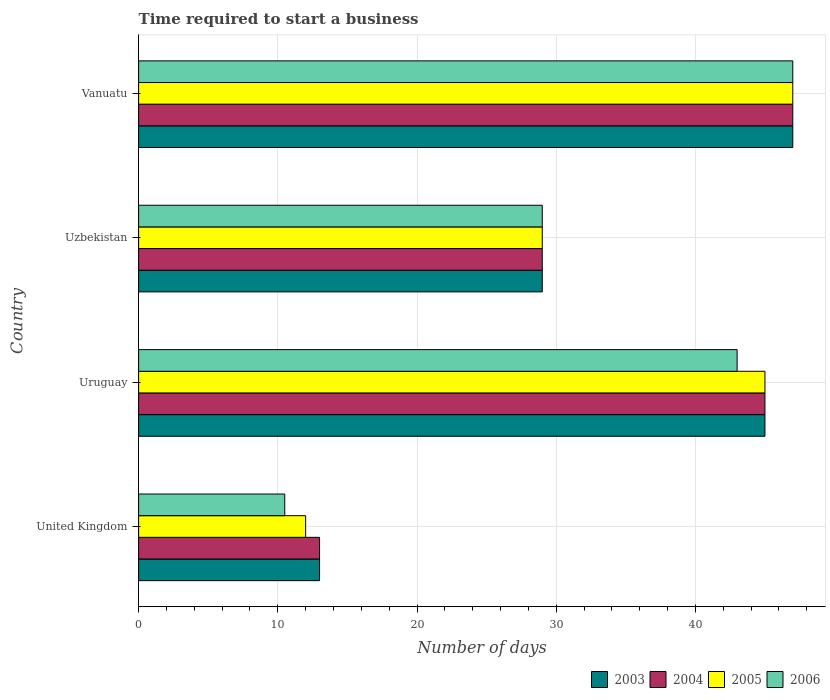How many different coloured bars are there?
Offer a terse response. 4. What is the label of the 3rd group of bars from the top?
Make the answer very short. Uruguay. In how many cases, is the number of bars for a given country not equal to the number of legend labels?
Your response must be concise. 0. What is the number of days required to start a business in 2003 in Vanuatu?
Offer a very short reply. 47. Across all countries, what is the minimum number of days required to start a business in 2006?
Give a very brief answer. 10.5. In which country was the number of days required to start a business in 2004 maximum?
Offer a terse response. Vanuatu. What is the total number of days required to start a business in 2005 in the graph?
Offer a very short reply. 133. What is the difference between the number of days required to start a business in 2003 in United Kingdom and that in Uzbekistan?
Provide a succinct answer. -16. What is the average number of days required to start a business in 2006 per country?
Provide a succinct answer. 32.38. What is the difference between the number of days required to start a business in 2005 and number of days required to start a business in 2003 in Uruguay?
Provide a short and direct response. 0. In how many countries, is the number of days required to start a business in 2006 greater than 28 days?
Provide a short and direct response. 3. What is the ratio of the number of days required to start a business in 2005 in United Kingdom to that in Vanuatu?
Give a very brief answer. 0.26. Is the number of days required to start a business in 2005 in United Kingdom less than that in Uruguay?
Provide a short and direct response. Yes. Is the difference between the number of days required to start a business in 2005 in United Kingdom and Uzbekistan greater than the difference between the number of days required to start a business in 2003 in United Kingdom and Uzbekistan?
Ensure brevity in your answer.  No. What is the difference between the highest and the lowest number of days required to start a business in 2006?
Provide a short and direct response. 36.5. Is the sum of the number of days required to start a business in 2005 in Uruguay and Vanuatu greater than the maximum number of days required to start a business in 2004 across all countries?
Your answer should be very brief. Yes. What does the 2nd bar from the bottom in Uruguay represents?
Provide a short and direct response. 2004. How many bars are there?
Keep it short and to the point. 16. Does the graph contain any zero values?
Offer a very short reply. No. How many legend labels are there?
Ensure brevity in your answer.  4. How are the legend labels stacked?
Give a very brief answer. Horizontal. What is the title of the graph?
Your response must be concise. Time required to start a business. Does "1968" appear as one of the legend labels in the graph?
Ensure brevity in your answer.  No. What is the label or title of the X-axis?
Keep it short and to the point. Number of days. What is the label or title of the Y-axis?
Offer a terse response. Country. What is the Number of days of 2003 in United Kingdom?
Make the answer very short. 13. What is the Number of days in 2004 in United Kingdom?
Your answer should be compact. 13. What is the Number of days in 2006 in United Kingdom?
Offer a very short reply. 10.5. What is the Number of days in 2003 in Vanuatu?
Keep it short and to the point. 47. What is the Number of days in 2005 in Vanuatu?
Make the answer very short. 47. Across all countries, what is the maximum Number of days in 2003?
Your response must be concise. 47. Across all countries, what is the maximum Number of days in 2004?
Make the answer very short. 47. Across all countries, what is the maximum Number of days in 2006?
Provide a short and direct response. 47. Across all countries, what is the minimum Number of days of 2003?
Make the answer very short. 13. Across all countries, what is the minimum Number of days of 2004?
Offer a very short reply. 13. Across all countries, what is the minimum Number of days of 2006?
Your answer should be very brief. 10.5. What is the total Number of days of 2003 in the graph?
Your response must be concise. 134. What is the total Number of days in 2004 in the graph?
Offer a terse response. 134. What is the total Number of days in 2005 in the graph?
Your answer should be compact. 133. What is the total Number of days of 2006 in the graph?
Offer a very short reply. 129.5. What is the difference between the Number of days in 2003 in United Kingdom and that in Uruguay?
Give a very brief answer. -32. What is the difference between the Number of days in 2004 in United Kingdom and that in Uruguay?
Keep it short and to the point. -32. What is the difference between the Number of days in 2005 in United Kingdom and that in Uruguay?
Keep it short and to the point. -33. What is the difference between the Number of days in 2006 in United Kingdom and that in Uruguay?
Ensure brevity in your answer.  -32.5. What is the difference between the Number of days of 2003 in United Kingdom and that in Uzbekistan?
Your answer should be compact. -16. What is the difference between the Number of days in 2004 in United Kingdom and that in Uzbekistan?
Provide a succinct answer. -16. What is the difference between the Number of days in 2005 in United Kingdom and that in Uzbekistan?
Your response must be concise. -17. What is the difference between the Number of days of 2006 in United Kingdom and that in Uzbekistan?
Give a very brief answer. -18.5. What is the difference between the Number of days of 2003 in United Kingdom and that in Vanuatu?
Ensure brevity in your answer.  -34. What is the difference between the Number of days in 2004 in United Kingdom and that in Vanuatu?
Offer a very short reply. -34. What is the difference between the Number of days of 2005 in United Kingdom and that in Vanuatu?
Give a very brief answer. -35. What is the difference between the Number of days in 2006 in United Kingdom and that in Vanuatu?
Offer a terse response. -36.5. What is the difference between the Number of days of 2005 in Uruguay and that in Uzbekistan?
Provide a short and direct response. 16. What is the difference between the Number of days in 2005 in Uruguay and that in Vanuatu?
Offer a very short reply. -2. What is the difference between the Number of days in 2006 in Uruguay and that in Vanuatu?
Your answer should be compact. -4. What is the difference between the Number of days in 2003 in Uzbekistan and that in Vanuatu?
Your answer should be compact. -18. What is the difference between the Number of days in 2004 in Uzbekistan and that in Vanuatu?
Ensure brevity in your answer.  -18. What is the difference between the Number of days in 2003 in United Kingdom and the Number of days in 2004 in Uruguay?
Provide a short and direct response. -32. What is the difference between the Number of days in 2003 in United Kingdom and the Number of days in 2005 in Uruguay?
Keep it short and to the point. -32. What is the difference between the Number of days in 2004 in United Kingdom and the Number of days in 2005 in Uruguay?
Keep it short and to the point. -32. What is the difference between the Number of days in 2004 in United Kingdom and the Number of days in 2006 in Uruguay?
Your answer should be compact. -30. What is the difference between the Number of days in 2005 in United Kingdom and the Number of days in 2006 in Uruguay?
Your answer should be compact. -31. What is the difference between the Number of days in 2003 in United Kingdom and the Number of days in 2004 in Uzbekistan?
Your answer should be compact. -16. What is the difference between the Number of days of 2003 in United Kingdom and the Number of days of 2006 in Uzbekistan?
Offer a very short reply. -16. What is the difference between the Number of days of 2003 in United Kingdom and the Number of days of 2004 in Vanuatu?
Your answer should be very brief. -34. What is the difference between the Number of days in 2003 in United Kingdom and the Number of days in 2005 in Vanuatu?
Ensure brevity in your answer.  -34. What is the difference between the Number of days in 2003 in United Kingdom and the Number of days in 2006 in Vanuatu?
Your answer should be very brief. -34. What is the difference between the Number of days of 2004 in United Kingdom and the Number of days of 2005 in Vanuatu?
Offer a very short reply. -34. What is the difference between the Number of days in 2004 in United Kingdom and the Number of days in 2006 in Vanuatu?
Provide a short and direct response. -34. What is the difference between the Number of days of 2005 in United Kingdom and the Number of days of 2006 in Vanuatu?
Make the answer very short. -35. What is the difference between the Number of days in 2003 in Uruguay and the Number of days in 2005 in Uzbekistan?
Make the answer very short. 16. What is the difference between the Number of days of 2004 in Uruguay and the Number of days of 2005 in Uzbekistan?
Your response must be concise. 16. What is the difference between the Number of days in 2003 in Uruguay and the Number of days in 2005 in Vanuatu?
Ensure brevity in your answer.  -2. What is the difference between the Number of days in 2004 in Uruguay and the Number of days in 2005 in Vanuatu?
Make the answer very short. -2. What is the difference between the Number of days in 2003 in Uzbekistan and the Number of days in 2005 in Vanuatu?
Ensure brevity in your answer.  -18. What is the difference between the Number of days in 2004 in Uzbekistan and the Number of days in 2005 in Vanuatu?
Keep it short and to the point. -18. What is the average Number of days of 2003 per country?
Your answer should be very brief. 33.5. What is the average Number of days in 2004 per country?
Make the answer very short. 33.5. What is the average Number of days of 2005 per country?
Make the answer very short. 33.25. What is the average Number of days in 2006 per country?
Make the answer very short. 32.38. What is the difference between the Number of days of 2003 and Number of days of 2004 in United Kingdom?
Your response must be concise. 0. What is the difference between the Number of days in 2003 and Number of days in 2006 in United Kingdom?
Your answer should be very brief. 2.5. What is the difference between the Number of days in 2004 and Number of days in 2005 in United Kingdom?
Keep it short and to the point. 1. What is the difference between the Number of days of 2004 and Number of days of 2006 in United Kingdom?
Ensure brevity in your answer.  2.5. What is the difference between the Number of days in 2004 and Number of days in 2005 in Uruguay?
Offer a terse response. 0. What is the difference between the Number of days of 2004 and Number of days of 2006 in Uruguay?
Your answer should be compact. 2. What is the difference between the Number of days of 2003 and Number of days of 2004 in Uzbekistan?
Offer a very short reply. 0. What is the difference between the Number of days of 2005 and Number of days of 2006 in Uzbekistan?
Offer a terse response. 0. What is the difference between the Number of days in 2003 and Number of days in 2004 in Vanuatu?
Offer a very short reply. 0. What is the difference between the Number of days in 2003 and Number of days in 2006 in Vanuatu?
Ensure brevity in your answer.  0. What is the difference between the Number of days in 2004 and Number of days in 2005 in Vanuatu?
Make the answer very short. 0. What is the difference between the Number of days of 2004 and Number of days of 2006 in Vanuatu?
Your answer should be compact. 0. What is the difference between the Number of days in 2005 and Number of days in 2006 in Vanuatu?
Provide a succinct answer. 0. What is the ratio of the Number of days in 2003 in United Kingdom to that in Uruguay?
Give a very brief answer. 0.29. What is the ratio of the Number of days of 2004 in United Kingdom to that in Uruguay?
Ensure brevity in your answer.  0.29. What is the ratio of the Number of days in 2005 in United Kingdom to that in Uruguay?
Your response must be concise. 0.27. What is the ratio of the Number of days of 2006 in United Kingdom to that in Uruguay?
Keep it short and to the point. 0.24. What is the ratio of the Number of days of 2003 in United Kingdom to that in Uzbekistan?
Keep it short and to the point. 0.45. What is the ratio of the Number of days in 2004 in United Kingdom to that in Uzbekistan?
Give a very brief answer. 0.45. What is the ratio of the Number of days of 2005 in United Kingdom to that in Uzbekistan?
Make the answer very short. 0.41. What is the ratio of the Number of days of 2006 in United Kingdom to that in Uzbekistan?
Ensure brevity in your answer.  0.36. What is the ratio of the Number of days in 2003 in United Kingdom to that in Vanuatu?
Ensure brevity in your answer.  0.28. What is the ratio of the Number of days in 2004 in United Kingdom to that in Vanuatu?
Provide a succinct answer. 0.28. What is the ratio of the Number of days in 2005 in United Kingdom to that in Vanuatu?
Your answer should be compact. 0.26. What is the ratio of the Number of days of 2006 in United Kingdom to that in Vanuatu?
Give a very brief answer. 0.22. What is the ratio of the Number of days in 2003 in Uruguay to that in Uzbekistan?
Your answer should be very brief. 1.55. What is the ratio of the Number of days in 2004 in Uruguay to that in Uzbekistan?
Provide a succinct answer. 1.55. What is the ratio of the Number of days in 2005 in Uruguay to that in Uzbekistan?
Provide a short and direct response. 1.55. What is the ratio of the Number of days of 2006 in Uruguay to that in Uzbekistan?
Your response must be concise. 1.48. What is the ratio of the Number of days of 2003 in Uruguay to that in Vanuatu?
Your answer should be very brief. 0.96. What is the ratio of the Number of days in 2004 in Uruguay to that in Vanuatu?
Ensure brevity in your answer.  0.96. What is the ratio of the Number of days of 2005 in Uruguay to that in Vanuatu?
Your answer should be compact. 0.96. What is the ratio of the Number of days of 2006 in Uruguay to that in Vanuatu?
Your answer should be compact. 0.91. What is the ratio of the Number of days of 2003 in Uzbekistan to that in Vanuatu?
Provide a short and direct response. 0.62. What is the ratio of the Number of days of 2004 in Uzbekistan to that in Vanuatu?
Your answer should be compact. 0.62. What is the ratio of the Number of days of 2005 in Uzbekistan to that in Vanuatu?
Your answer should be very brief. 0.62. What is the ratio of the Number of days in 2006 in Uzbekistan to that in Vanuatu?
Ensure brevity in your answer.  0.62. What is the difference between the highest and the second highest Number of days of 2003?
Provide a succinct answer. 2. What is the difference between the highest and the second highest Number of days of 2005?
Provide a succinct answer. 2. What is the difference between the highest and the second highest Number of days of 2006?
Keep it short and to the point. 4. What is the difference between the highest and the lowest Number of days of 2006?
Keep it short and to the point. 36.5. 